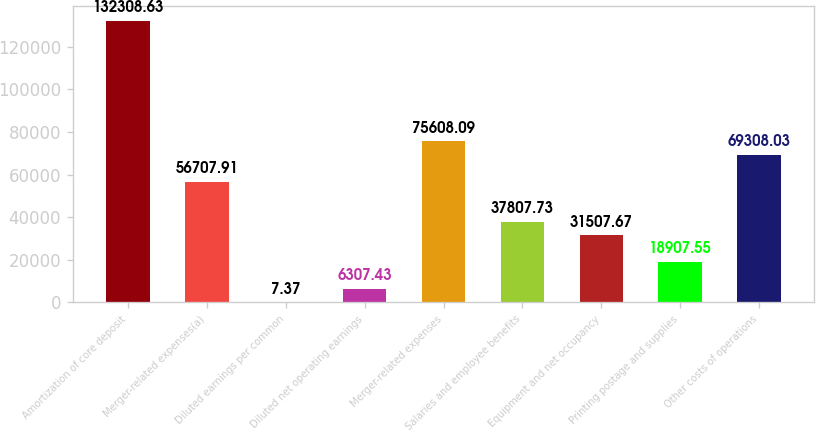<chart> <loc_0><loc_0><loc_500><loc_500><bar_chart><fcel>Amortization of core deposit<fcel>Merger-related expenses(a)<fcel>Diluted earnings per common<fcel>Diluted net operating earnings<fcel>Merger-related expenses<fcel>Salaries and employee benefits<fcel>Equipment and net occupancy<fcel>Printing postage and supplies<fcel>Other costs of operations<nl><fcel>132309<fcel>56707.9<fcel>7.37<fcel>6307.43<fcel>75608.1<fcel>37807.7<fcel>31507.7<fcel>18907.5<fcel>69308<nl></chart> 